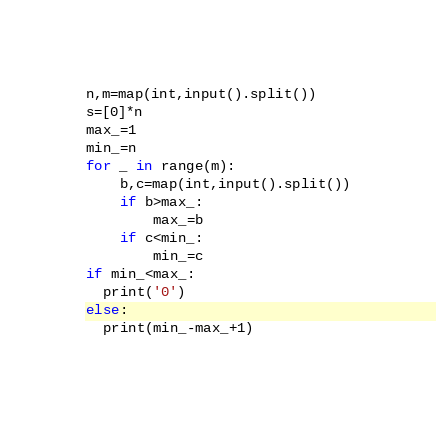Convert code to text. <code><loc_0><loc_0><loc_500><loc_500><_Python_>n,m=map(int,input().split())
s=[0]*n
max_=1
min_=n
for _ in range(m):
    b,c=map(int,input().split())
    if b>max_:
        max_=b
    if c<min_:
        min_=c
if min_<max_:
  print('0')
else:
  print(min_-max_+1)</code> 